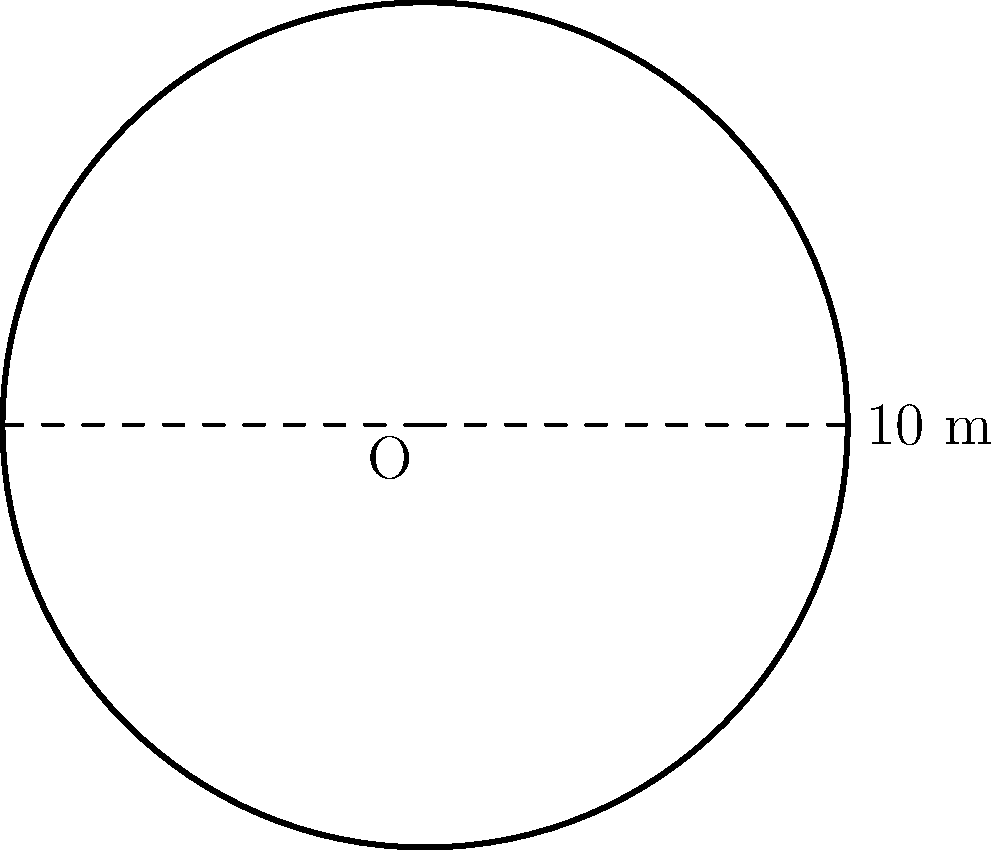At the ancient stone circle of Callanish on the Isle of Lewis, there's a circular formation of standing stones. If the diameter of this formation is 10 meters, what is the area enclosed by these stones? Round your answer to the nearest square meter. To find the area of the circular stone formation, we need to follow these steps:

1) First, recall the formula for the area of a circle:
   $$A = \pi r^2$$
   where $A$ is the area and $r$ is the radius.

2) We're given the diameter, which is 10 meters. The radius is half of the diameter:
   $$r = \frac{10}{2} = 5\text{ meters}$$

3) Now, let's substitute this into our area formula:
   $$A = \pi (5)^2 = 25\pi\text{ square meters}$$

4) Using $\pi \approx 3.14159$, we can calculate:
   $$A \approx 25 \times 3.14159 = 78.53975\text{ square meters}$$

5) Rounding to the nearest square meter:
   $$A \approx 79\text{ square meters}$$

This area represents the sacred space enclosed by our ancient Scottish stone circle, a testament to the mathematical knowledge of our ancestors.
Answer: 79 square meters 